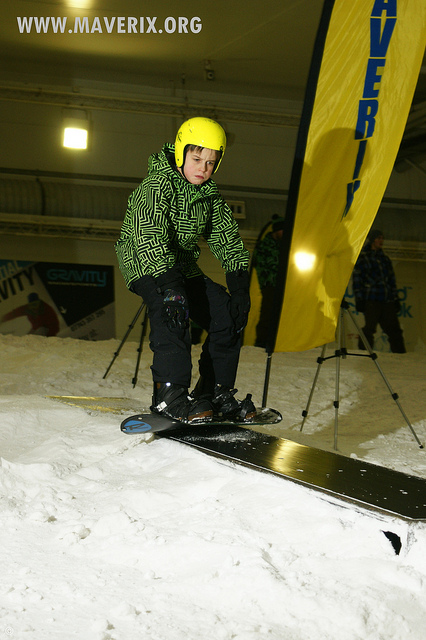Identify the text displayed in this image. WWW.MAVERIX.ORG AVERIY GRAVITY VITY 